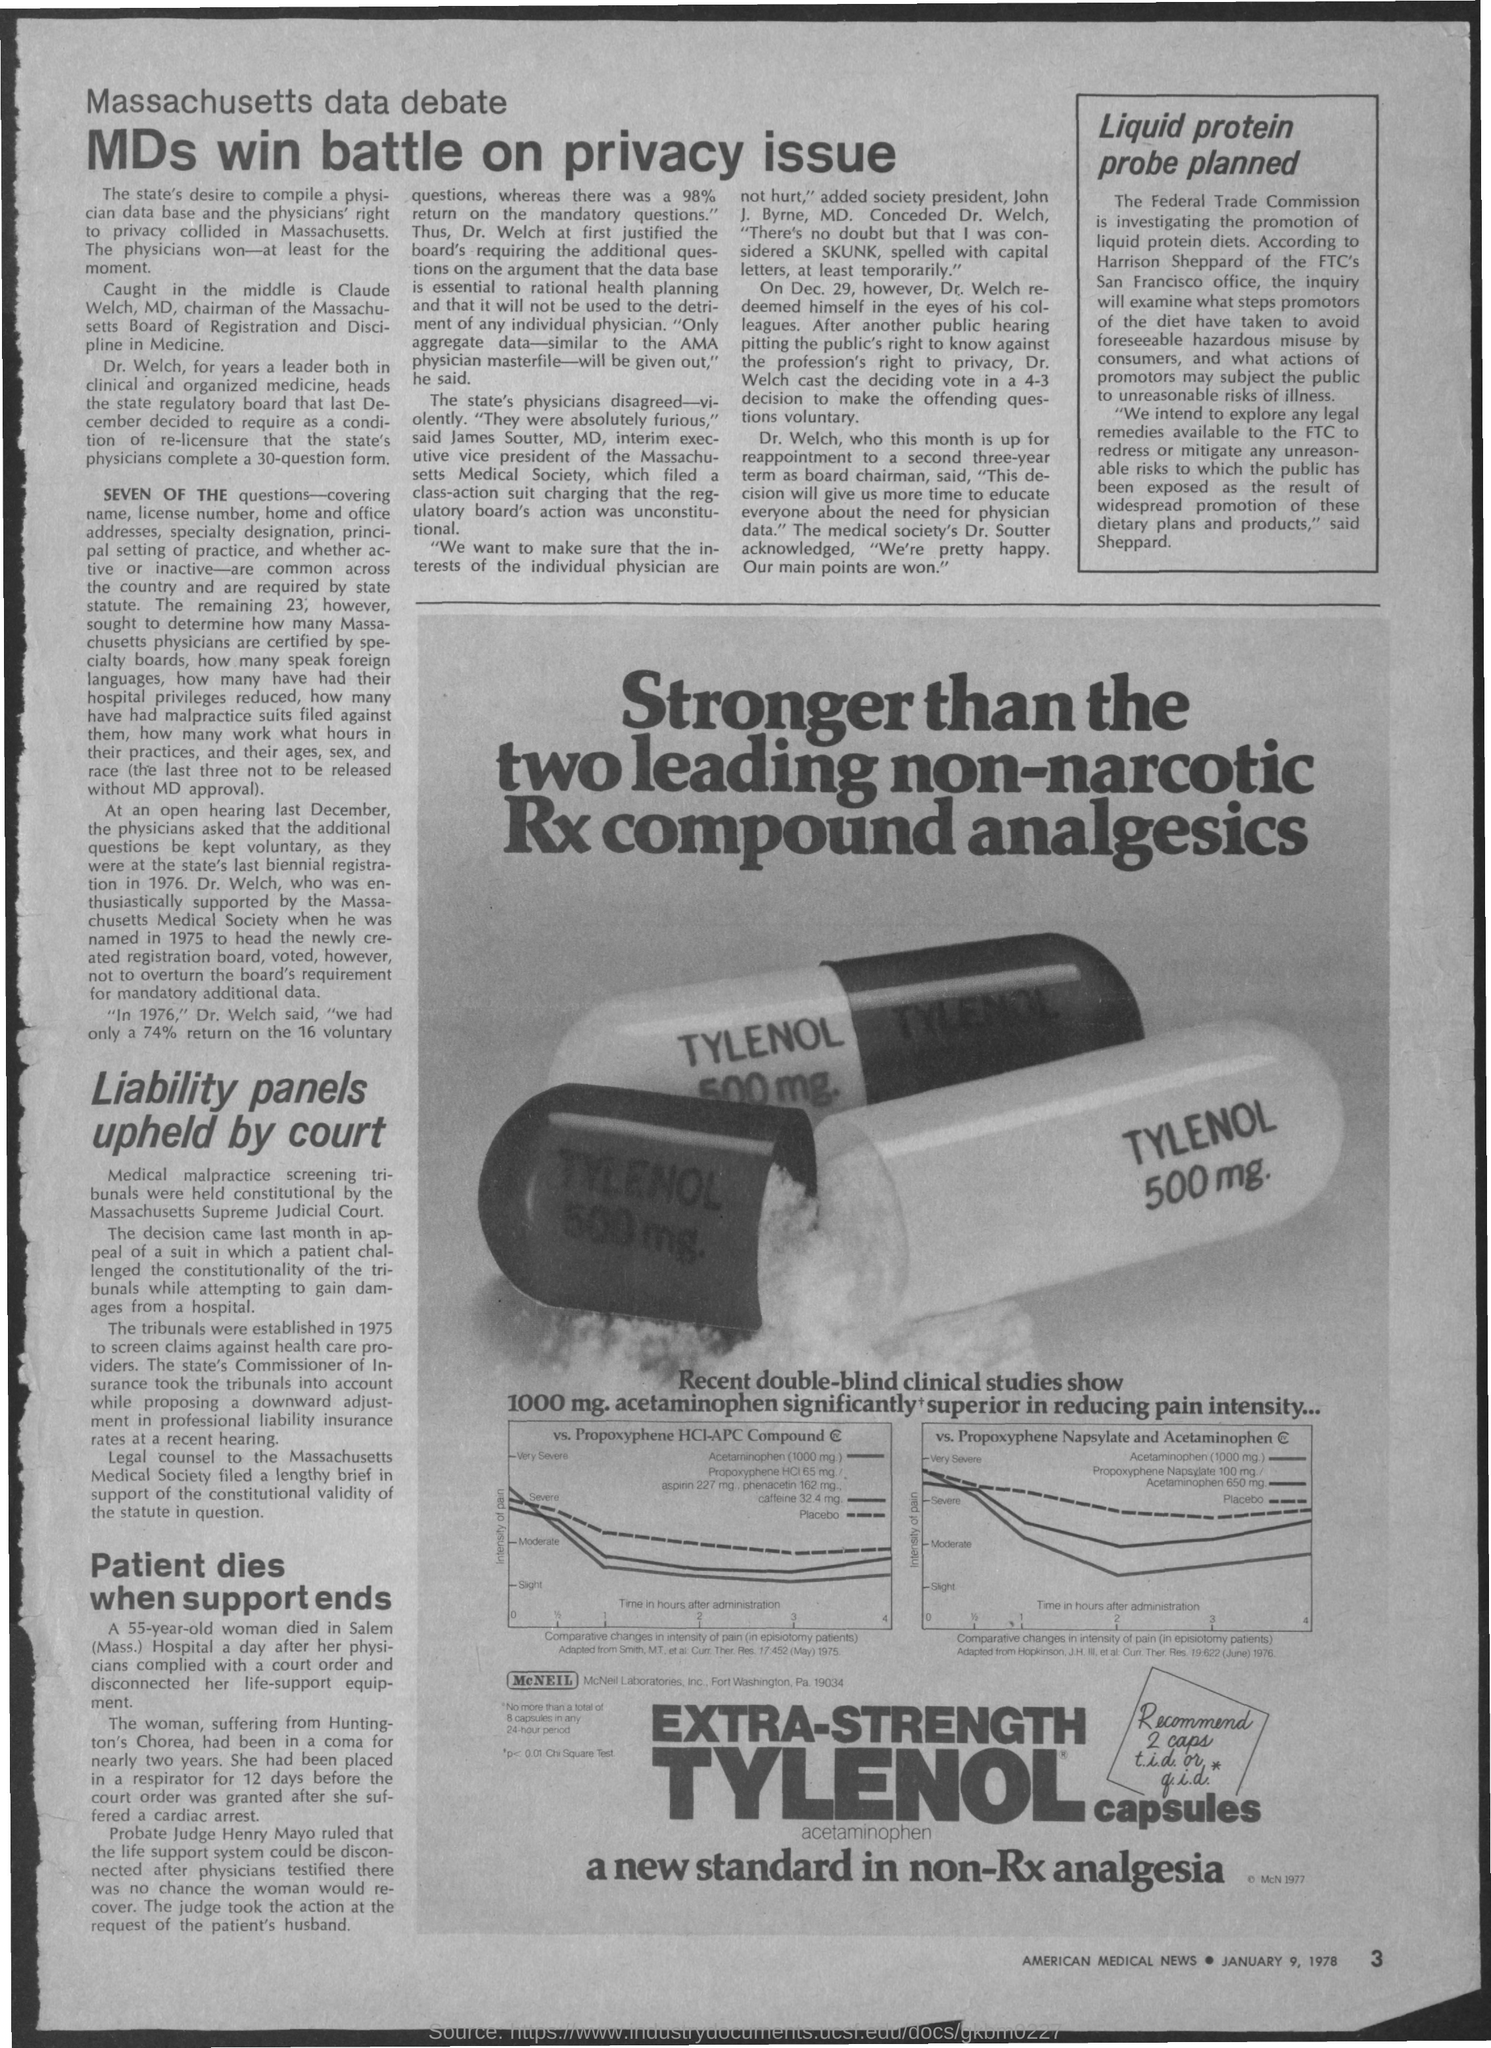Point out several critical features in this image. In the battle over privacy issues, doctors are the ones who ultimately emerge victorious. The date on the document is January 9, 1978. 